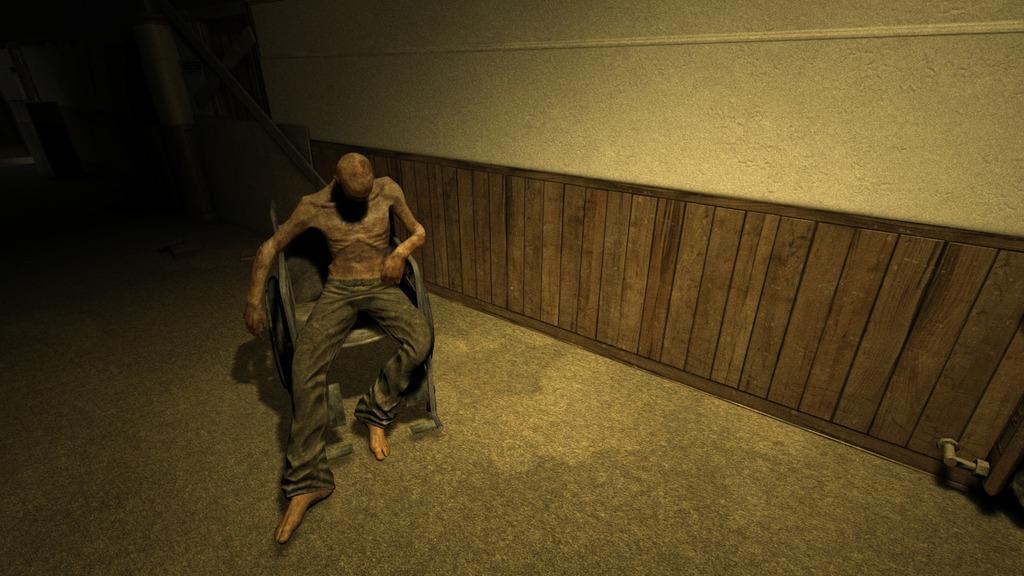Could you give a brief overview of what you see in this image? There is a person wearing black pant is sitting in a chair and there is a wooden object attached to the wall beside him. 